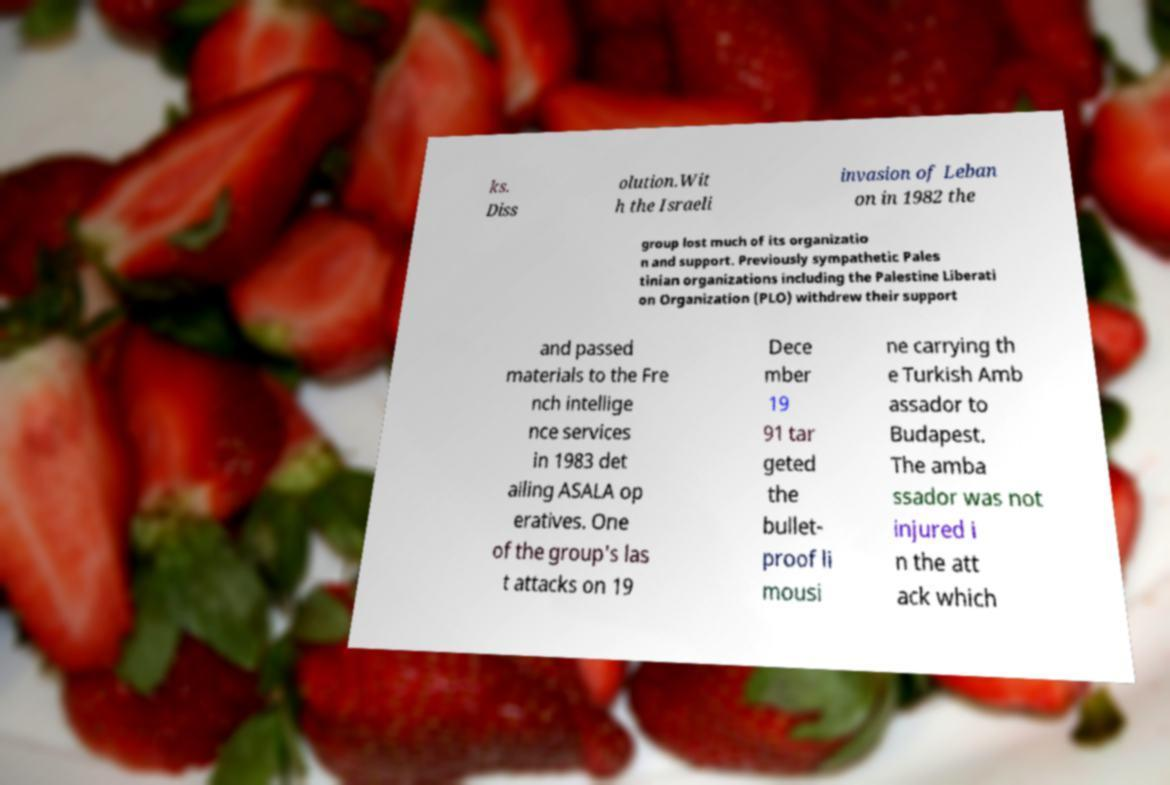Could you extract and type out the text from this image? ks. Diss olution.Wit h the Israeli invasion of Leban on in 1982 the group lost much of its organizatio n and support. Previously sympathetic Pales tinian organizations including the Palestine Liberati on Organization (PLO) withdrew their support and passed materials to the Fre nch intellige nce services in 1983 det ailing ASALA op eratives. One of the group's las t attacks on 19 Dece mber 19 91 tar geted the bullet- proof li mousi ne carrying th e Turkish Amb assador to Budapest. The amba ssador was not injured i n the att ack which 